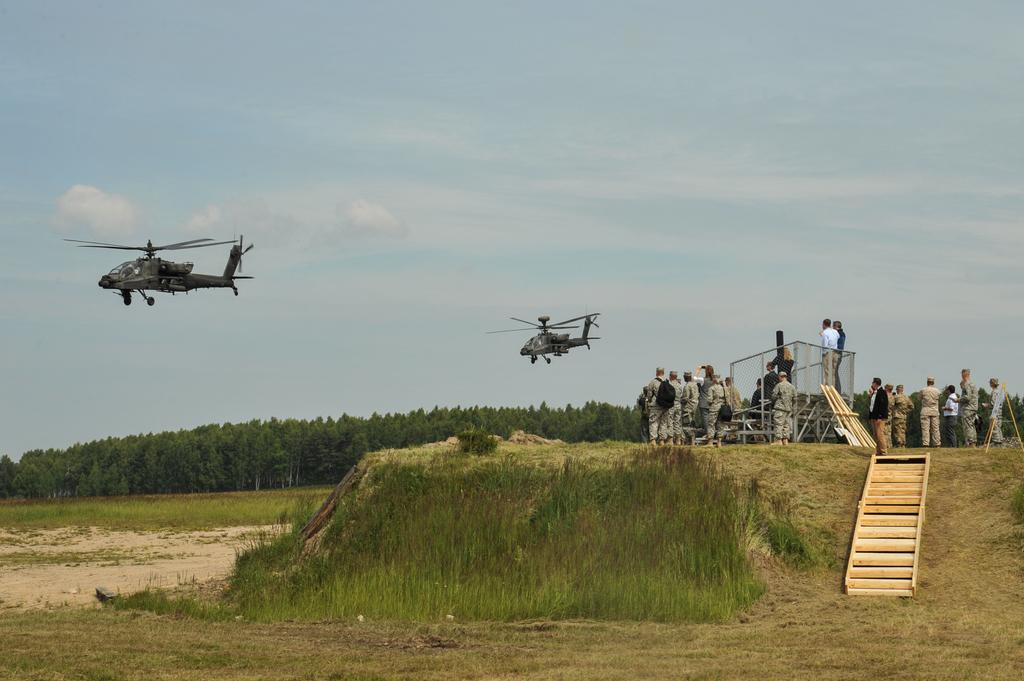What is happening in the air in the image? There are helicopters flying in the air. What can be seen on the ground in the image? The ground is visible in the image, and there is grass and trees present. Are there any people in the image? Yes, there are people in the image. What architectural feature can be seen in the image? There are steps in the image. What else is visible in the image? There are objects in the image. What is visible in the background of the image? The sky is visible in the background, and there are clouds present. Where is the store located in the image? There is no store present in the image. Can you see a crow in the image? There is no crow present in the image. What type of drink is being served in the image? There is no drink mentioned or visible in the image. 